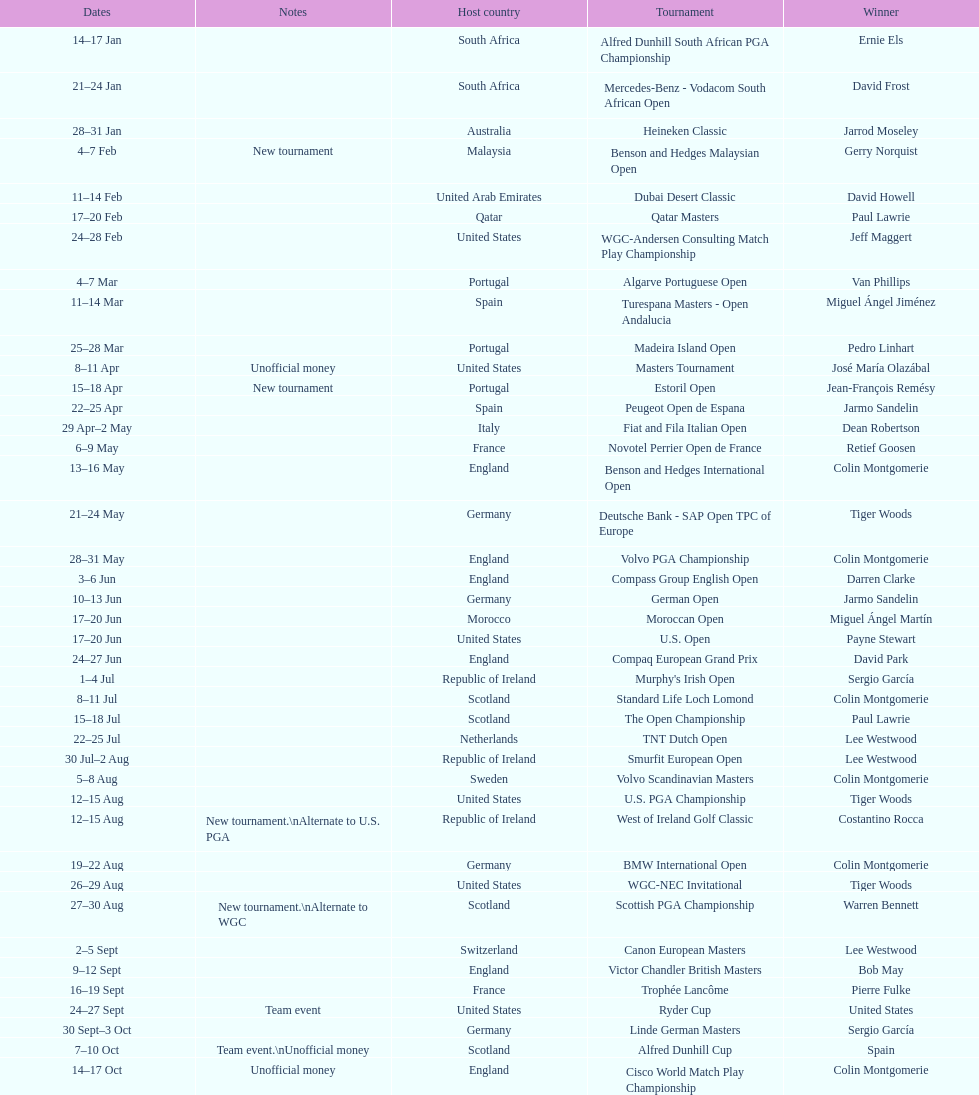What was the country listed the first time there was a new tournament? Malaysia. 